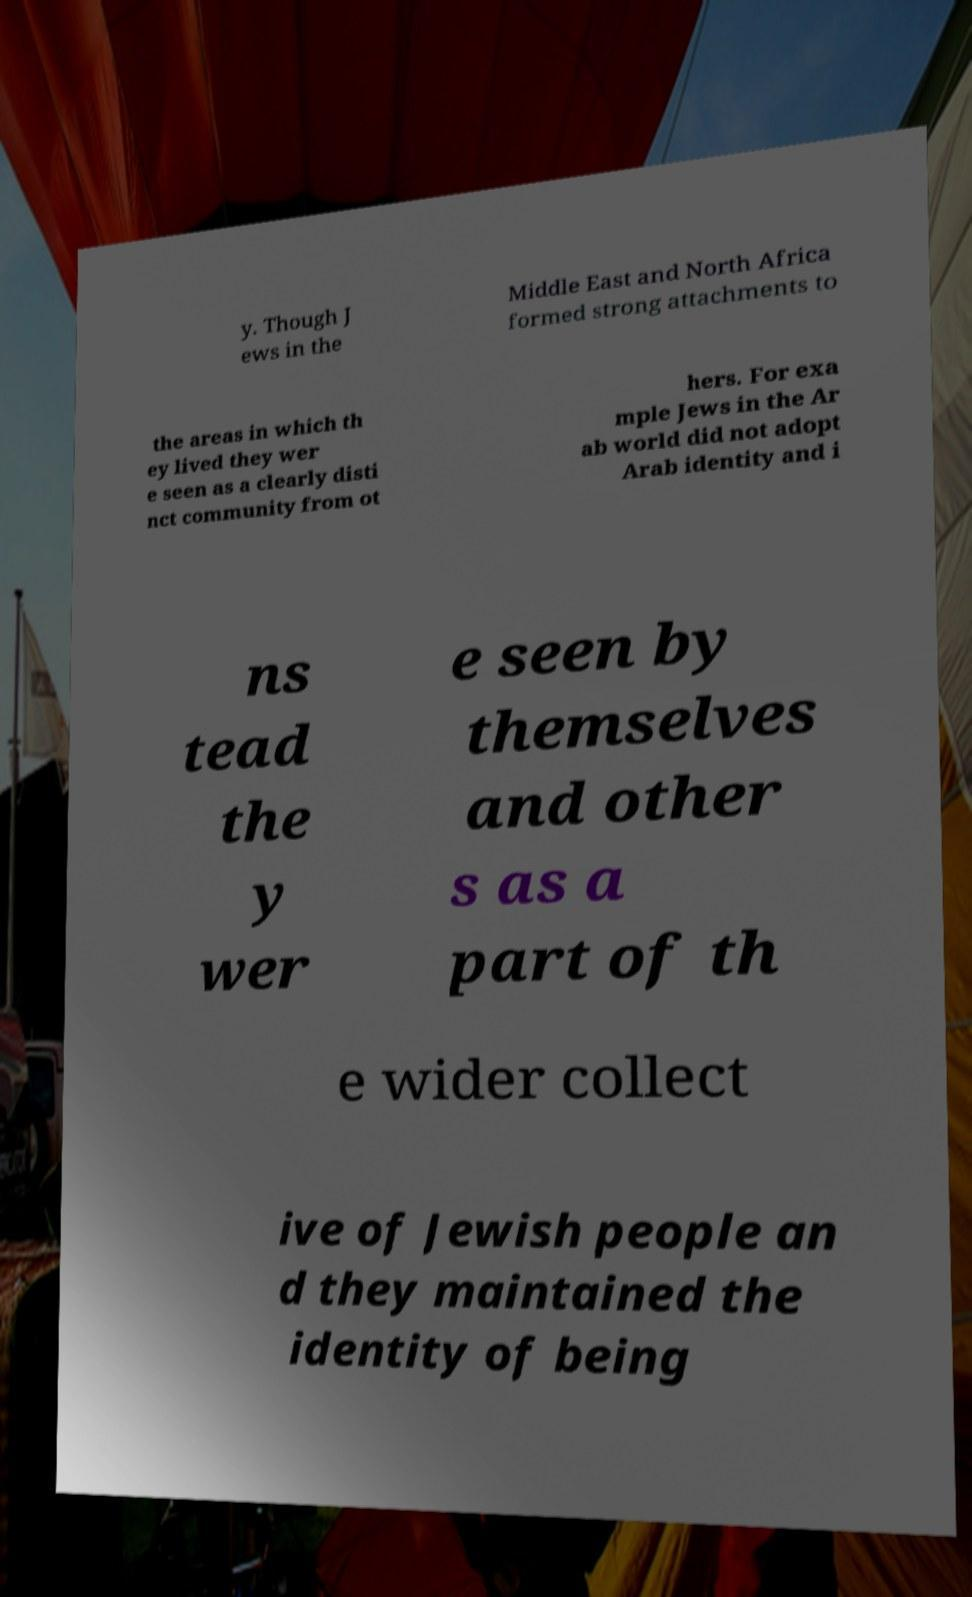Could you assist in decoding the text presented in this image and type it out clearly? y. Though J ews in the Middle East and North Africa formed strong attachments to the areas in which th ey lived they wer e seen as a clearly disti nct community from ot hers. For exa mple Jews in the Ar ab world did not adopt Arab identity and i ns tead the y wer e seen by themselves and other s as a part of th e wider collect ive of Jewish people an d they maintained the identity of being 